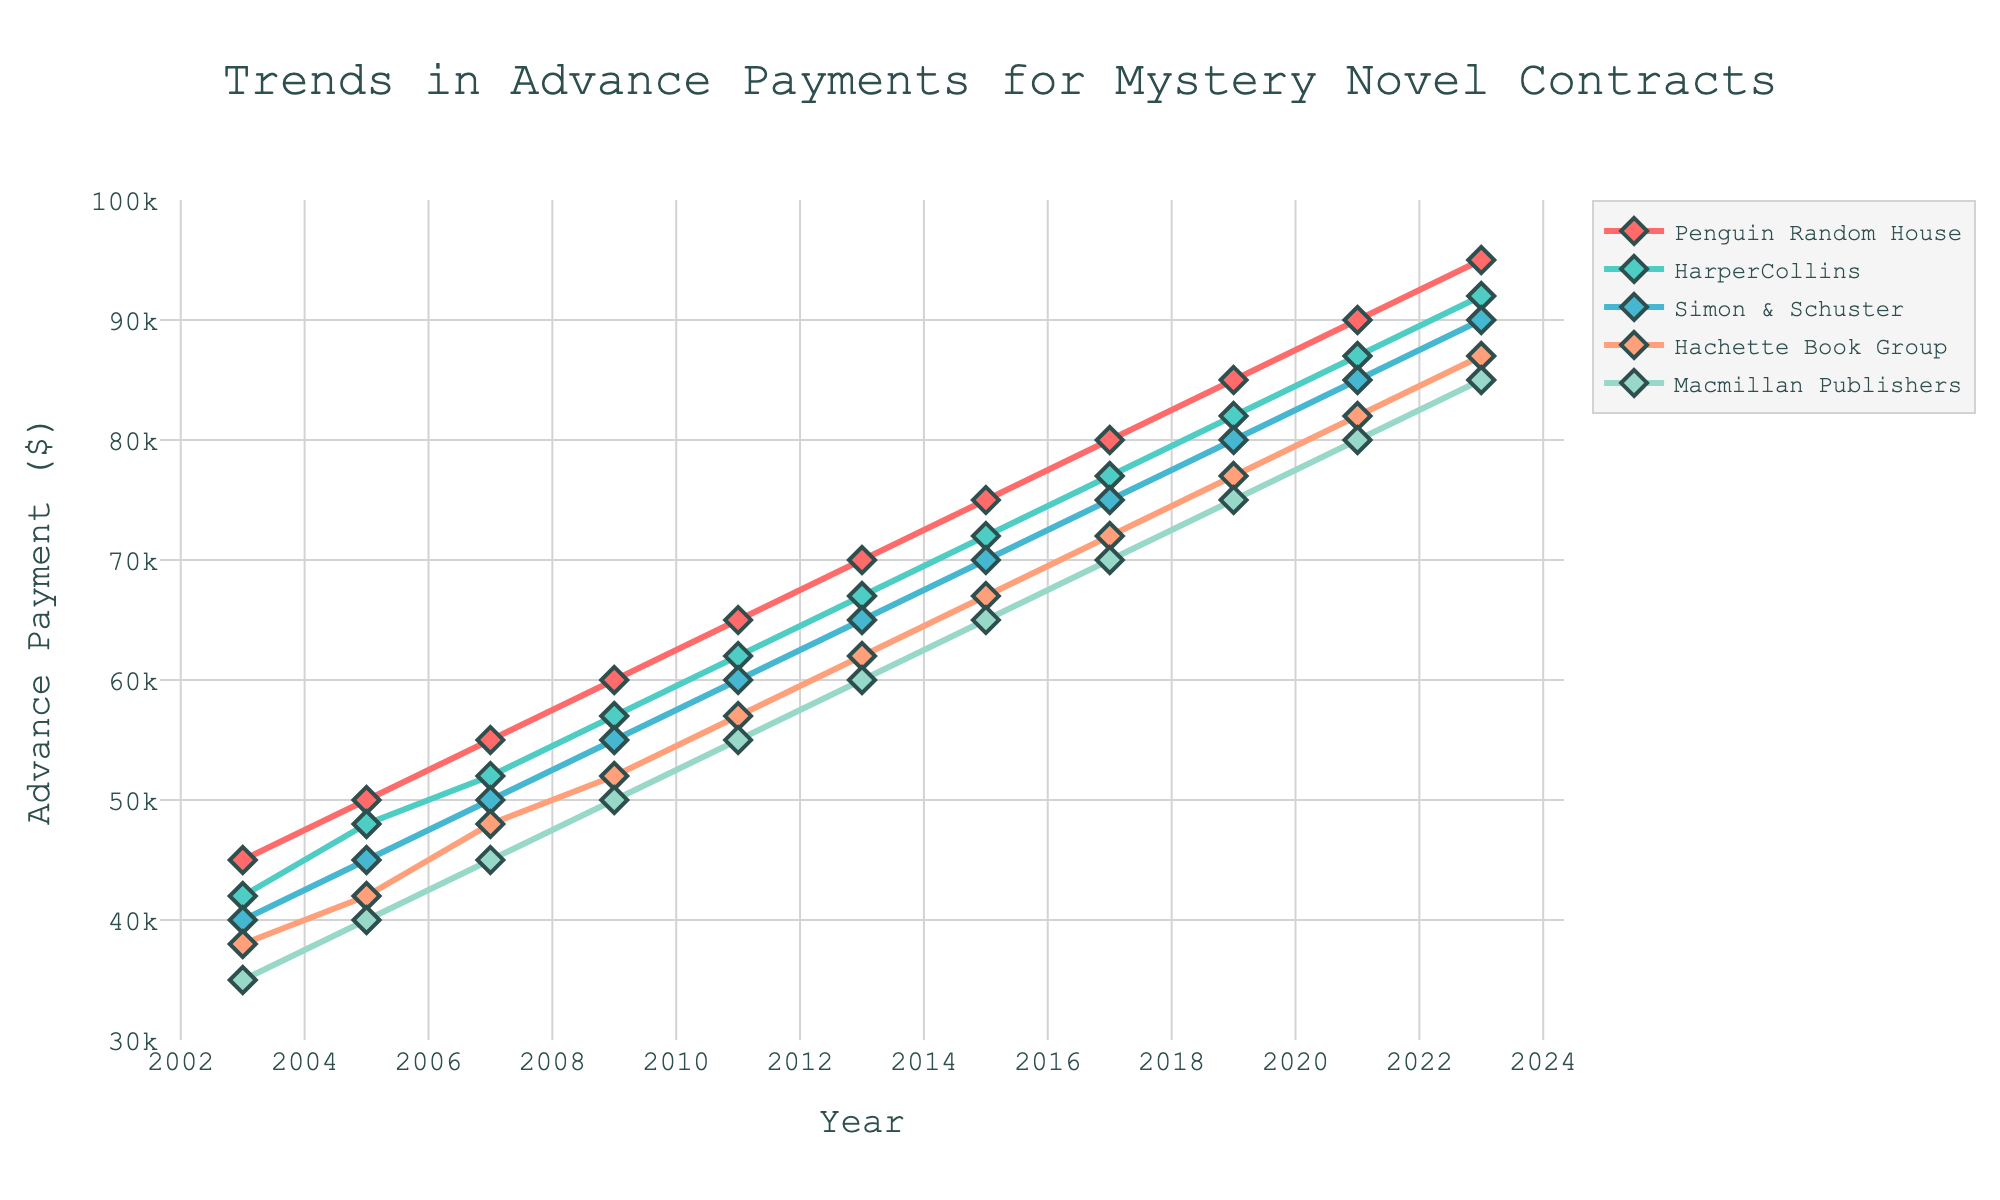What's the average advance payment by Macmillan Publishers over the 20-year period? To calculate the average, sum up the advance payments by Macmillan Publishers across all provided years and then divide by the number of years (11). The values are 35000, 40000, 45000, 50000, 55000, 60000, 65000, 70000, 75000, 80000, 85000, whose sum is 605000. Therefore, 605000 divided by 11 gives the average.
Answer: 55000 Which publishing house had the highest advance payment in 2023? Review the data for the year 2023 and compare the advance payments for all publishing houses. The values are: Penguin Random House (95000), HarperCollins (92000), Simon & Schuster (90000), Hachette Book Group (87000), Macmillan Publishers (85000). Penguin Random House has the highest value.
Answer: Penguin Random House Between 2003 and 2023, which publishing house showed the largest increase in advance payments? Calculate the difference in advance payments from 2003 to 2023 for each publishing house and compare these differences. The differences are: Penguin Random House (95000 - 45000 = 50000), HarperCollins (92000 - 42000 = 50000), Simon & Schuster (90000 - 40000 = 50000), Hachette Book Group (87000 - 38000 = 49000), Macmillan Publishers (85000 - 35000 = 50000). Penguin Random House, HarperCollins, Simon & Schuster, and Macmillan Publishers all showed the largest increase.
Answer: Penguin Random House, HarperCollins, Simon & Schuster, Macmillan Publishers How did the advance payments for HarperCollins change from 2005 to 2015? Look at the advance payments for HarperCollins in 2005 and 2015. The values are 48000 in 2005 and 72000 in 2015. Compute the change by subtracting 48000 from 72000.
Answer: Increased by 24000 What's the difference in advance payments between Penguin Random House and Macmillan Publishers in 2023? Subtract Macmillan Publishers' advance payment in 2023 (85000) from Penguin Random House's advance payment in 2023 (95000).
Answer: 10000 Among the publishing houses, which one had consistently increasing advance payments over the 20-year period? Examine the trend lines for each publishing house to see if they all have a positive slope without any dips. Every publishing house in the plot shows a consistent increase in advance payments over the years.
Answer: All of them In 2019, was the advance payment by Hachette Book Group higher or lower than that by Simon & Schuster? Look at the 2019 values for Hachette Book Group (77000) and Simon & Schuster (80000) and compare them.
Answer: Lower What was the trend in advance payments for Simon & Schuster from 2007 to 2023? Observe the values for Simon & Schuster across the years 2007 (50000) to 2023 (90000). The trend shows a steady increase in advance payments.
Answer: Steady increase Which publishing house had the closest advance payment to $70,000 in 2015? Review the 2015 data: Penguin Random House (75000), HarperCollins (72000), Simon & Schuster (70000), Hachette Book Group (67000), and Macmillan Publishers (65000). Simon & Schuster has the closest value to $70000.
Answer: Simon & Schuster 